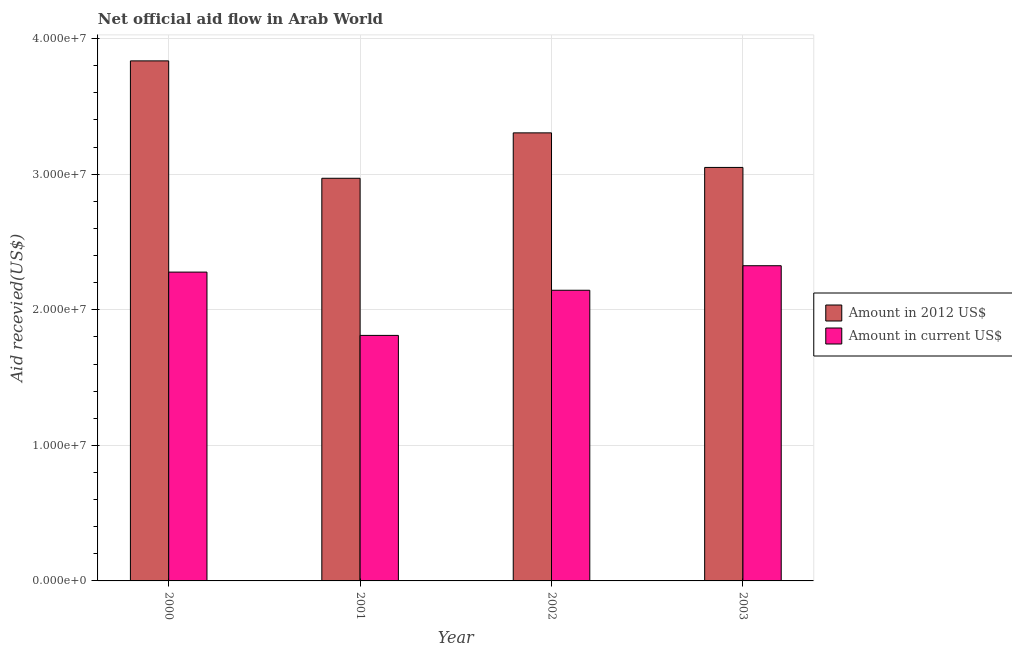How many groups of bars are there?
Your response must be concise. 4. How many bars are there on the 2nd tick from the left?
Your answer should be compact. 2. What is the label of the 2nd group of bars from the left?
Your answer should be very brief. 2001. In how many cases, is the number of bars for a given year not equal to the number of legend labels?
Give a very brief answer. 0. What is the amount of aid received(expressed in us$) in 2001?
Provide a succinct answer. 1.81e+07. Across all years, what is the maximum amount of aid received(expressed in us$)?
Provide a short and direct response. 2.32e+07. Across all years, what is the minimum amount of aid received(expressed in us$)?
Offer a very short reply. 1.81e+07. In which year was the amount of aid received(expressed in us$) maximum?
Ensure brevity in your answer.  2003. In which year was the amount of aid received(expressed in us$) minimum?
Your answer should be very brief. 2001. What is the total amount of aid received(expressed in 2012 us$) in the graph?
Give a very brief answer. 1.32e+08. What is the difference between the amount of aid received(expressed in 2012 us$) in 2000 and that in 2003?
Offer a terse response. 7.86e+06. What is the difference between the amount of aid received(expressed in us$) in 2001 and the amount of aid received(expressed in 2012 us$) in 2002?
Your answer should be very brief. -3.33e+06. What is the average amount of aid received(expressed in 2012 us$) per year?
Offer a terse response. 3.29e+07. In how many years, is the amount of aid received(expressed in 2012 us$) greater than 24000000 US$?
Give a very brief answer. 4. What is the ratio of the amount of aid received(expressed in us$) in 2000 to that in 2002?
Make the answer very short. 1.06. What is the difference between the highest and the lowest amount of aid received(expressed in 2012 us$)?
Your answer should be very brief. 8.66e+06. Is the sum of the amount of aid received(expressed in us$) in 2000 and 2002 greater than the maximum amount of aid received(expressed in 2012 us$) across all years?
Your answer should be very brief. Yes. What does the 1st bar from the left in 2002 represents?
Give a very brief answer. Amount in 2012 US$. What does the 1st bar from the right in 2003 represents?
Your answer should be compact. Amount in current US$. What is the difference between two consecutive major ticks on the Y-axis?
Offer a very short reply. 1.00e+07. Are the values on the major ticks of Y-axis written in scientific E-notation?
Ensure brevity in your answer.  Yes. Does the graph contain any zero values?
Provide a succinct answer. No. Where does the legend appear in the graph?
Ensure brevity in your answer.  Center right. How many legend labels are there?
Offer a very short reply. 2. What is the title of the graph?
Offer a terse response. Net official aid flow in Arab World. Does "Domestic Liabilities" appear as one of the legend labels in the graph?
Your answer should be compact. No. What is the label or title of the X-axis?
Provide a short and direct response. Year. What is the label or title of the Y-axis?
Provide a short and direct response. Aid recevied(US$). What is the Aid recevied(US$) of Amount in 2012 US$ in 2000?
Keep it short and to the point. 3.84e+07. What is the Aid recevied(US$) of Amount in current US$ in 2000?
Offer a very short reply. 2.28e+07. What is the Aid recevied(US$) in Amount in 2012 US$ in 2001?
Ensure brevity in your answer.  2.97e+07. What is the Aid recevied(US$) of Amount in current US$ in 2001?
Ensure brevity in your answer.  1.81e+07. What is the Aid recevied(US$) in Amount in 2012 US$ in 2002?
Keep it short and to the point. 3.30e+07. What is the Aid recevied(US$) of Amount in current US$ in 2002?
Your answer should be very brief. 2.14e+07. What is the Aid recevied(US$) in Amount in 2012 US$ in 2003?
Offer a terse response. 3.05e+07. What is the Aid recevied(US$) in Amount in current US$ in 2003?
Provide a succinct answer. 2.32e+07. Across all years, what is the maximum Aid recevied(US$) in Amount in 2012 US$?
Your answer should be very brief. 3.84e+07. Across all years, what is the maximum Aid recevied(US$) of Amount in current US$?
Keep it short and to the point. 2.32e+07. Across all years, what is the minimum Aid recevied(US$) of Amount in 2012 US$?
Offer a terse response. 2.97e+07. Across all years, what is the minimum Aid recevied(US$) in Amount in current US$?
Offer a terse response. 1.81e+07. What is the total Aid recevied(US$) in Amount in 2012 US$ in the graph?
Offer a very short reply. 1.32e+08. What is the total Aid recevied(US$) of Amount in current US$ in the graph?
Give a very brief answer. 8.56e+07. What is the difference between the Aid recevied(US$) of Amount in 2012 US$ in 2000 and that in 2001?
Offer a terse response. 8.66e+06. What is the difference between the Aid recevied(US$) in Amount in current US$ in 2000 and that in 2001?
Provide a short and direct response. 4.67e+06. What is the difference between the Aid recevied(US$) in Amount in 2012 US$ in 2000 and that in 2002?
Your answer should be very brief. 5.31e+06. What is the difference between the Aid recevied(US$) in Amount in current US$ in 2000 and that in 2002?
Keep it short and to the point. 1.34e+06. What is the difference between the Aid recevied(US$) in Amount in 2012 US$ in 2000 and that in 2003?
Give a very brief answer. 7.86e+06. What is the difference between the Aid recevied(US$) in Amount in current US$ in 2000 and that in 2003?
Keep it short and to the point. -4.70e+05. What is the difference between the Aid recevied(US$) in Amount in 2012 US$ in 2001 and that in 2002?
Your answer should be compact. -3.35e+06. What is the difference between the Aid recevied(US$) in Amount in current US$ in 2001 and that in 2002?
Offer a terse response. -3.33e+06. What is the difference between the Aid recevied(US$) in Amount in 2012 US$ in 2001 and that in 2003?
Keep it short and to the point. -8.00e+05. What is the difference between the Aid recevied(US$) in Amount in current US$ in 2001 and that in 2003?
Provide a short and direct response. -5.14e+06. What is the difference between the Aid recevied(US$) of Amount in 2012 US$ in 2002 and that in 2003?
Offer a terse response. 2.55e+06. What is the difference between the Aid recevied(US$) of Amount in current US$ in 2002 and that in 2003?
Give a very brief answer. -1.81e+06. What is the difference between the Aid recevied(US$) in Amount in 2012 US$ in 2000 and the Aid recevied(US$) in Amount in current US$ in 2001?
Ensure brevity in your answer.  2.02e+07. What is the difference between the Aid recevied(US$) in Amount in 2012 US$ in 2000 and the Aid recevied(US$) in Amount in current US$ in 2002?
Make the answer very short. 1.69e+07. What is the difference between the Aid recevied(US$) in Amount in 2012 US$ in 2000 and the Aid recevied(US$) in Amount in current US$ in 2003?
Provide a succinct answer. 1.51e+07. What is the difference between the Aid recevied(US$) in Amount in 2012 US$ in 2001 and the Aid recevied(US$) in Amount in current US$ in 2002?
Offer a very short reply. 8.26e+06. What is the difference between the Aid recevied(US$) of Amount in 2012 US$ in 2001 and the Aid recevied(US$) of Amount in current US$ in 2003?
Provide a short and direct response. 6.45e+06. What is the difference between the Aid recevied(US$) in Amount in 2012 US$ in 2002 and the Aid recevied(US$) in Amount in current US$ in 2003?
Your response must be concise. 9.80e+06. What is the average Aid recevied(US$) of Amount in 2012 US$ per year?
Your response must be concise. 3.29e+07. What is the average Aid recevied(US$) of Amount in current US$ per year?
Keep it short and to the point. 2.14e+07. In the year 2000, what is the difference between the Aid recevied(US$) of Amount in 2012 US$ and Aid recevied(US$) of Amount in current US$?
Make the answer very short. 1.56e+07. In the year 2001, what is the difference between the Aid recevied(US$) of Amount in 2012 US$ and Aid recevied(US$) of Amount in current US$?
Your response must be concise. 1.16e+07. In the year 2002, what is the difference between the Aid recevied(US$) of Amount in 2012 US$ and Aid recevied(US$) of Amount in current US$?
Your answer should be very brief. 1.16e+07. In the year 2003, what is the difference between the Aid recevied(US$) in Amount in 2012 US$ and Aid recevied(US$) in Amount in current US$?
Make the answer very short. 7.25e+06. What is the ratio of the Aid recevied(US$) in Amount in 2012 US$ in 2000 to that in 2001?
Give a very brief answer. 1.29. What is the ratio of the Aid recevied(US$) in Amount in current US$ in 2000 to that in 2001?
Ensure brevity in your answer.  1.26. What is the ratio of the Aid recevied(US$) of Amount in 2012 US$ in 2000 to that in 2002?
Give a very brief answer. 1.16. What is the ratio of the Aid recevied(US$) in Amount in current US$ in 2000 to that in 2002?
Your response must be concise. 1.06. What is the ratio of the Aid recevied(US$) in Amount in 2012 US$ in 2000 to that in 2003?
Make the answer very short. 1.26. What is the ratio of the Aid recevied(US$) of Amount in current US$ in 2000 to that in 2003?
Give a very brief answer. 0.98. What is the ratio of the Aid recevied(US$) in Amount in 2012 US$ in 2001 to that in 2002?
Keep it short and to the point. 0.9. What is the ratio of the Aid recevied(US$) in Amount in current US$ in 2001 to that in 2002?
Make the answer very short. 0.84. What is the ratio of the Aid recevied(US$) of Amount in 2012 US$ in 2001 to that in 2003?
Offer a very short reply. 0.97. What is the ratio of the Aid recevied(US$) of Amount in current US$ in 2001 to that in 2003?
Keep it short and to the point. 0.78. What is the ratio of the Aid recevied(US$) of Amount in 2012 US$ in 2002 to that in 2003?
Your response must be concise. 1.08. What is the ratio of the Aid recevied(US$) of Amount in current US$ in 2002 to that in 2003?
Provide a succinct answer. 0.92. What is the difference between the highest and the second highest Aid recevied(US$) in Amount in 2012 US$?
Offer a terse response. 5.31e+06. What is the difference between the highest and the second highest Aid recevied(US$) in Amount in current US$?
Ensure brevity in your answer.  4.70e+05. What is the difference between the highest and the lowest Aid recevied(US$) of Amount in 2012 US$?
Offer a very short reply. 8.66e+06. What is the difference between the highest and the lowest Aid recevied(US$) of Amount in current US$?
Offer a very short reply. 5.14e+06. 